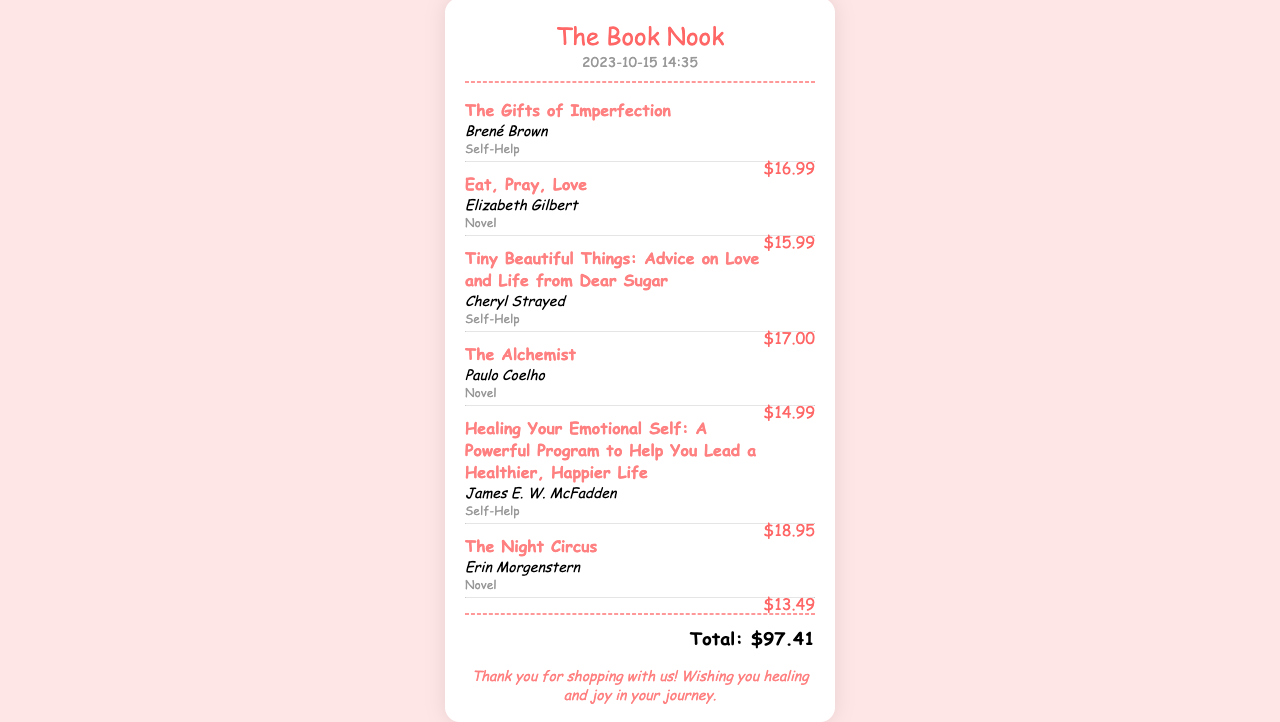What is the store name? The store name is prominently displayed at the top of the receipt.
Answer: The Book Nook What is the total amount spent? The total amount is clearly stated at the bottom of the receipt after listing all items.
Answer: $97.41 How many self-help books were purchased? By counting the items listed under the Self-Help category, we can determine the number of self-help books.
Answer: 3 Who authored "The Alchemist"? The author of each book is noted immediately below the title on the receipt.
Answer: Paulo Coelho What is the date of the purchase? The date of purchase is located near the store name at the top of the receipt.
Answer: 2023-10-15 Which novel has the lowest price? By comparing the prices of all novels, we can identify the one with the lowest price.
Answer: The Night Circus What is the price of "Healing Your Emotional Self"? The price is listed directly next to the title of the book on the receipt.
Answer: $18.95 What message is included at the bottom of the receipt? The receipt includes a message from the store, which is displayed at the bottom.
Answer: Thank you for shopping with us! Wishing you healing and joy in your journey How many novels were purchased? We can find the total number of items categorized as novels by counting them.
Answer: 3 